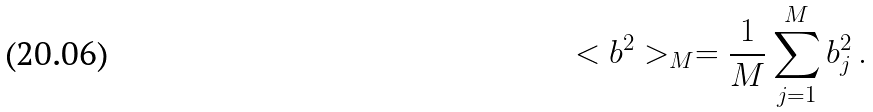Convert formula to latex. <formula><loc_0><loc_0><loc_500><loc_500>< b ^ { 2 } > _ { M } = \frac { 1 } { M } \sum _ { j = 1 } ^ { M } b ^ { 2 } _ { j } \, .</formula> 